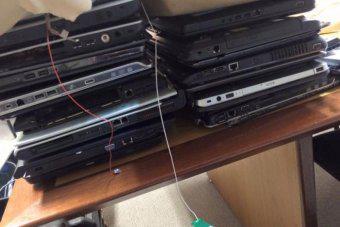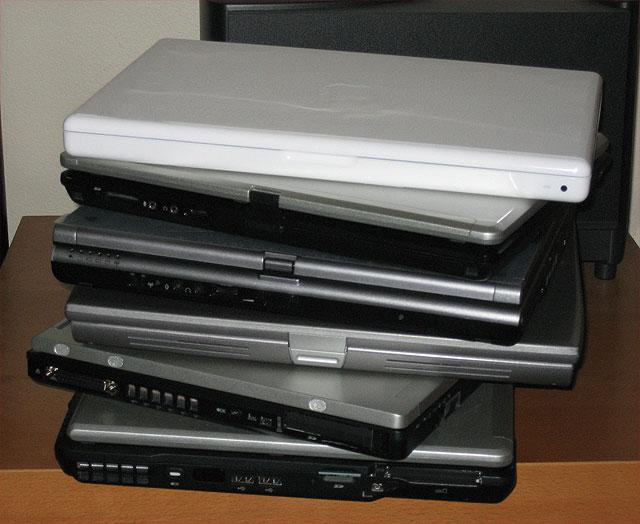The first image is the image on the left, the second image is the image on the right. Evaluate the accuracy of this statement regarding the images: "There is at least one laptop open with the keyboard showing.". Is it true? Answer yes or no. No. The first image is the image on the left, the second image is the image on the right. For the images displayed, is the sentence "In one image at least one laptop is open." factually correct? Answer yes or no. No. 